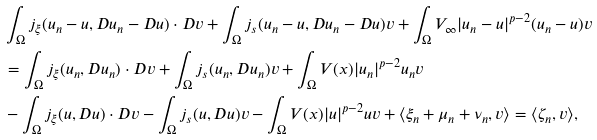<formula> <loc_0><loc_0><loc_500><loc_500>& \int _ { \Omega } j _ { \xi } ( u _ { n } - u , D u _ { n } - D u ) \cdot D v + \int _ { \Omega } j _ { s } ( u _ { n } - u , D u _ { n } - D u ) v + \int _ { \Omega } V _ { \infty } | u _ { n } - u | ^ { p - 2 } ( u _ { n } - u ) v \\ & = \int _ { \Omega } j _ { \xi } ( u _ { n } , D u _ { n } ) \cdot D v + \int _ { \Omega } j _ { s } ( u _ { n } , D u _ { n } ) v + \int _ { \Omega } V ( x ) | u _ { n } | ^ { p - 2 } u _ { n } v \\ & - \int _ { \Omega } j _ { \xi } ( u , D u ) \cdot D v - \int _ { \Omega } j _ { s } ( u , D u ) v - \int _ { \Omega } V ( x ) | u | ^ { p - 2 } u v + \langle \xi _ { n } + \mu _ { n } + \nu _ { n } , v \rangle = \langle \zeta _ { n } , v \rangle ,</formula> 